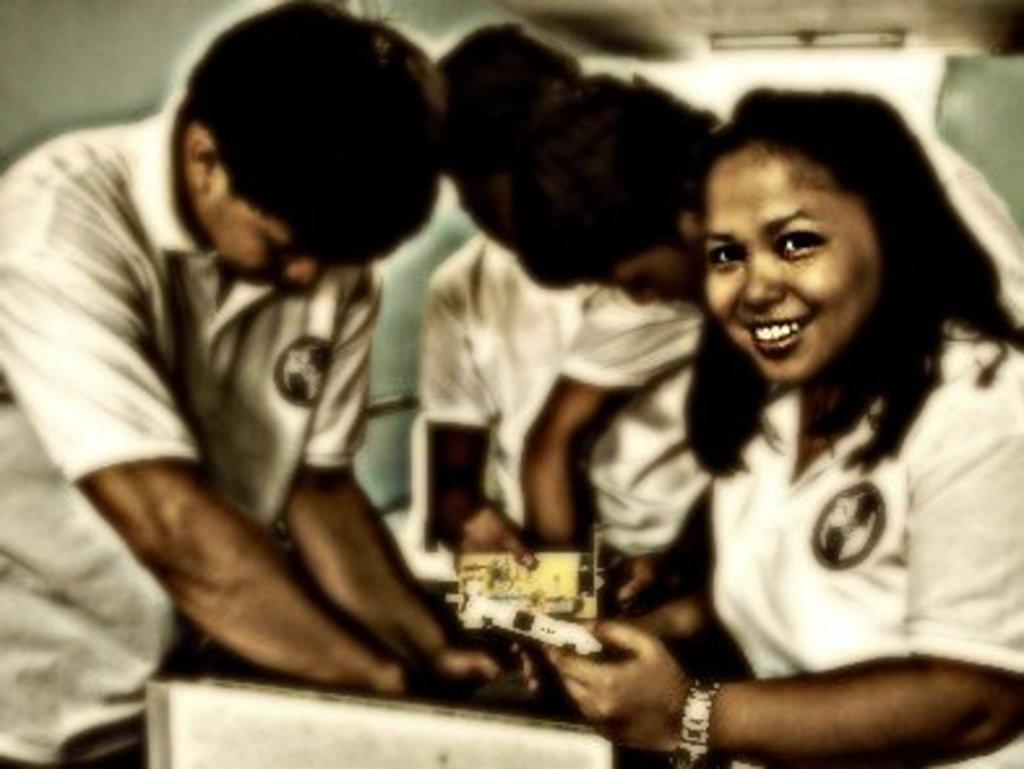What can be seen in the image? There is a group of people in the image. What are the people wearing? The people are wearing white color dresses. What is in front of the people? There is a box in front of the people. What are some people holding? Some people are holding something. What type of tin is being used to hold the water in the image? There is no tin present in the image, nor is there any water mentioned. 